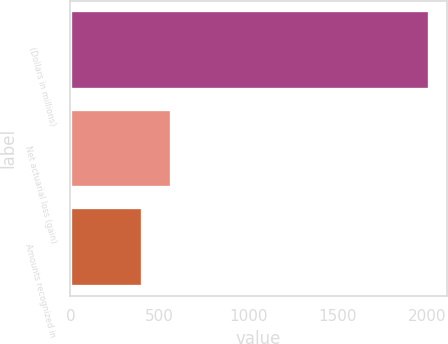<chart> <loc_0><loc_0><loc_500><loc_500><bar_chart><fcel>(Dollars in millions)<fcel>Net actuarial loss (gain)<fcel>Amounts recognized in<nl><fcel>2011<fcel>562.9<fcel>402<nl></chart> 